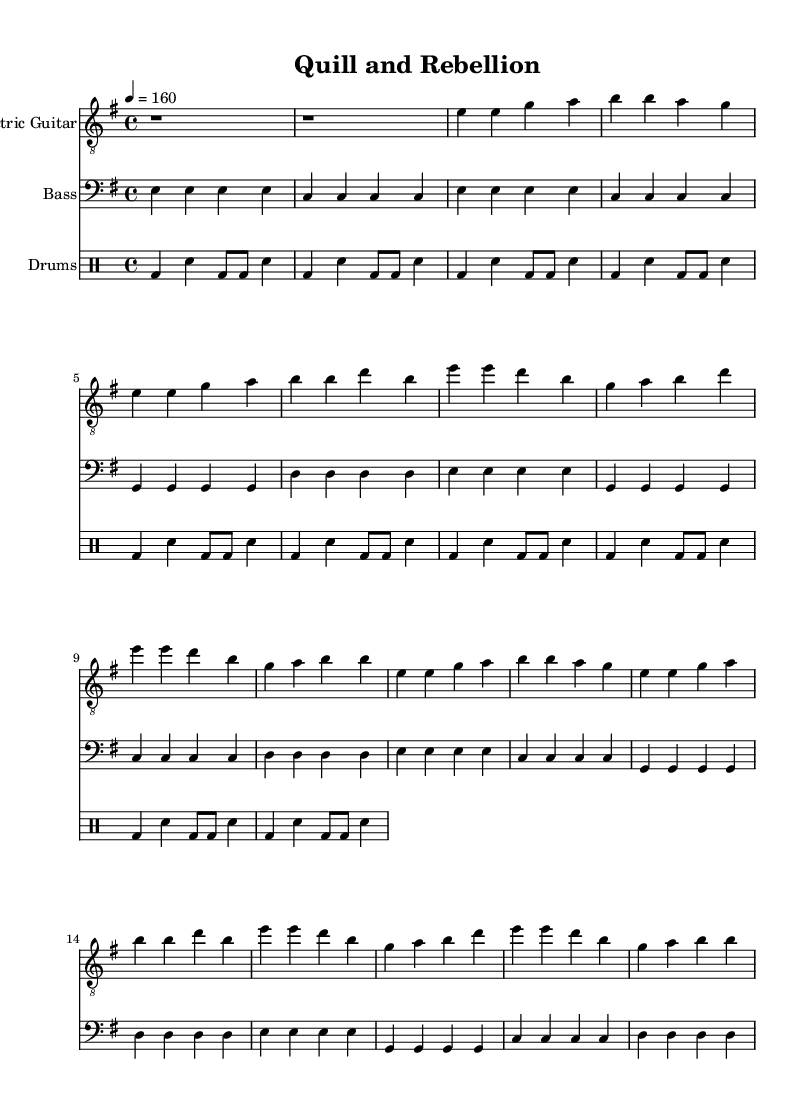What is the key signature of this music? The key signature is E minor, which corresponds to one sharp (F#). This can be identified by looking at the key signature shown at the beginning of the music.
Answer: E minor What is the time signature of this music? The time signature is 4/4, which indicates four beats per measure. This is seen at the beginning of the piece, where the signature is displayed.
Answer: 4/4 What is the tempo marking of this piece? The tempo marking is 160 beats per minute, as noted by the "4 = 160" indication within the score. This indicates how fast the piece should be played.
Answer: 160 How many measures are in the chorus section? The chorus section contains 8 measures. This can be determined by counting the measure bars in the chorus part, which is repeated twice in the score.
Answer: 8 What instrument is indicated for the electric guitar part? The instrument indicated is "Electric Guitar," as specified at the start of the guitar staff. This tells the performer which instrument to use for this part.
Answer: Electric Guitar What pattern is used in the drum part? The drum part uses a repeated pattern. The notation shows that the same rhythmic pattern is played multiple times, which indicates a cycle.
Answer: Repeated pattern What dynamics are applied in the performance? The sheet music does not specify any dynamic markings. This could imply that the piece is to be played with a consistent intensity unless indicated otherwise by the performer.
Answer: None 